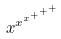<formula> <loc_0><loc_0><loc_500><loc_500>x ^ { x ^ { x ^ { + ^ { + ^ { + } } } } }</formula> 